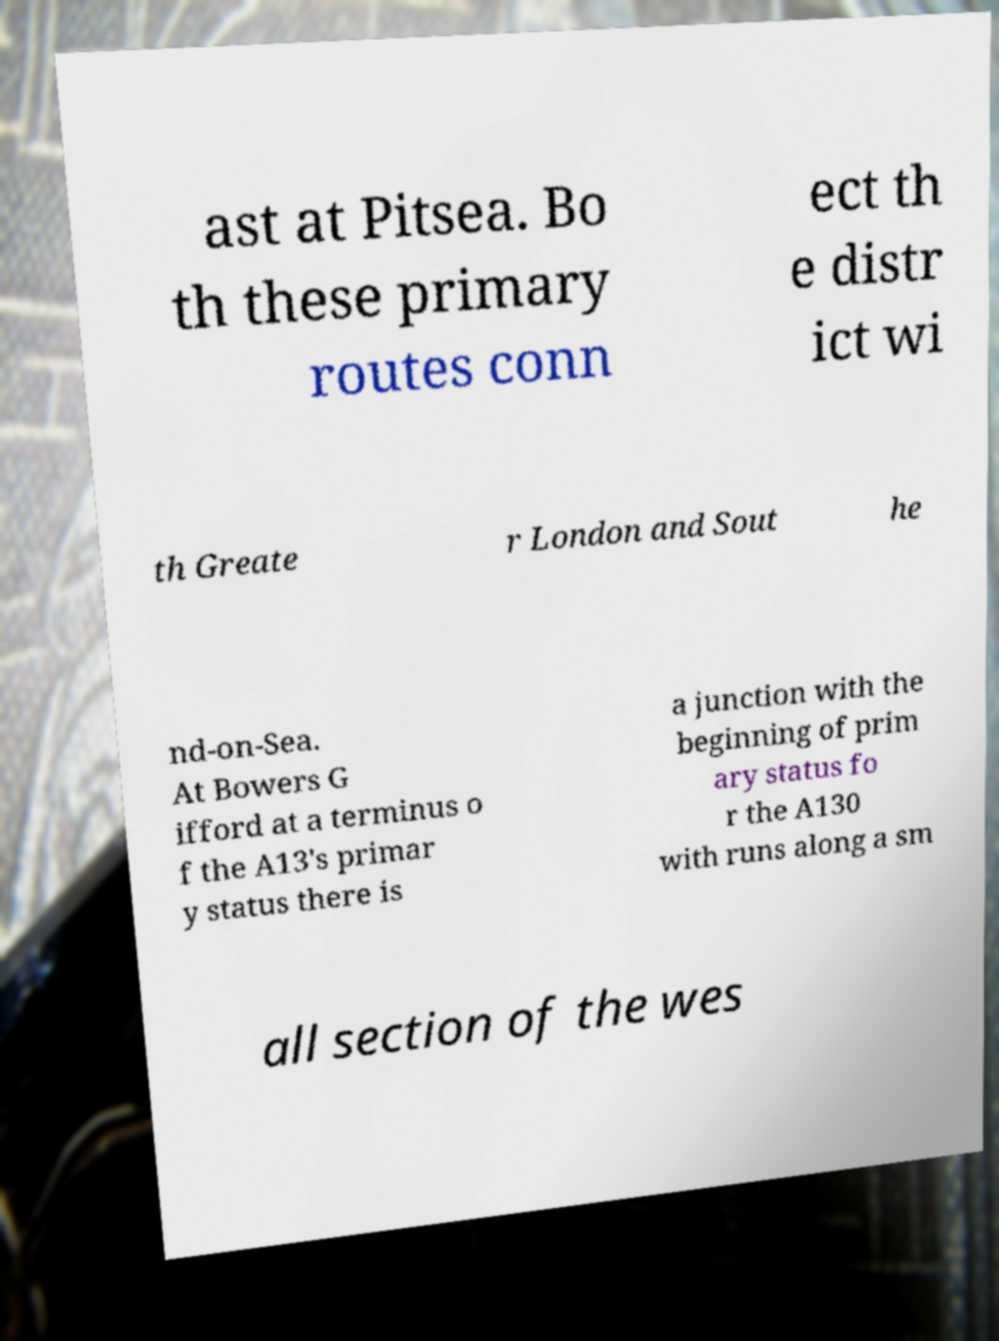There's text embedded in this image that I need extracted. Can you transcribe it verbatim? ast at Pitsea. Bo th these primary routes conn ect th e distr ict wi th Greate r London and Sout he nd-on-Sea. At Bowers G ifford at a terminus o f the A13's primar y status there is a junction with the beginning of prim ary status fo r the A130 with runs along a sm all section of the wes 